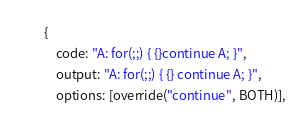<code> <loc_0><loc_0><loc_500><loc_500><_JavaScript_>        {
            code: "A: for(;;) { {}continue A; }",
            output: "A: for(;;) { {} continue A; }",
            options: [override("continue", BOTH)],</code> 